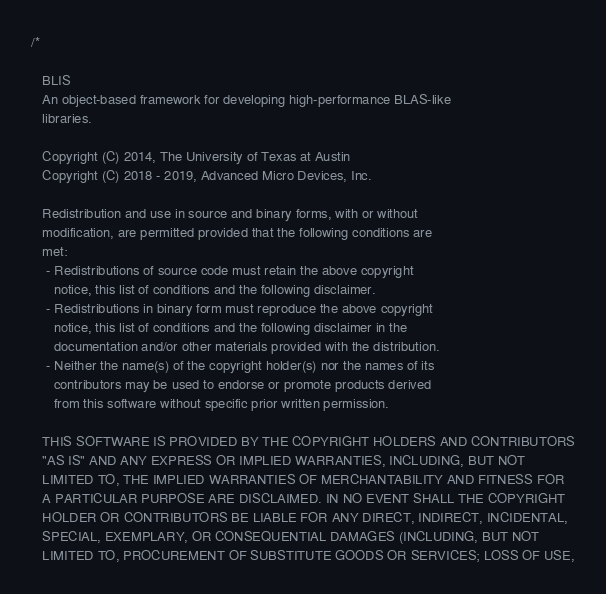Convert code to text. <code><loc_0><loc_0><loc_500><loc_500><_C_>/*

   BLIS
   An object-based framework for developing high-performance BLAS-like
   libraries.

   Copyright (C) 2014, The University of Texas at Austin
   Copyright (C) 2018 - 2019, Advanced Micro Devices, Inc.

   Redistribution and use in source and binary forms, with or without
   modification, are permitted provided that the following conditions are
   met:
    - Redistributions of source code must retain the above copyright
      notice, this list of conditions and the following disclaimer.
    - Redistributions in binary form must reproduce the above copyright
      notice, this list of conditions and the following disclaimer in the
      documentation and/or other materials provided with the distribution.
    - Neither the name(s) of the copyright holder(s) nor the names of its
      contributors may be used to endorse or promote products derived
      from this software without specific prior written permission.

   THIS SOFTWARE IS PROVIDED BY THE COPYRIGHT HOLDERS AND CONTRIBUTORS
   "AS IS" AND ANY EXPRESS OR IMPLIED WARRANTIES, INCLUDING, BUT NOT
   LIMITED TO, THE IMPLIED WARRANTIES OF MERCHANTABILITY AND FITNESS FOR
   A PARTICULAR PURPOSE ARE DISCLAIMED. IN NO EVENT SHALL THE COPYRIGHT
   HOLDER OR CONTRIBUTORS BE LIABLE FOR ANY DIRECT, INDIRECT, INCIDENTAL,
   SPECIAL, EXEMPLARY, OR CONSEQUENTIAL DAMAGES (INCLUDING, BUT NOT
   LIMITED TO, PROCUREMENT OF SUBSTITUTE GOODS OR SERVICES; LOSS OF USE,</code> 